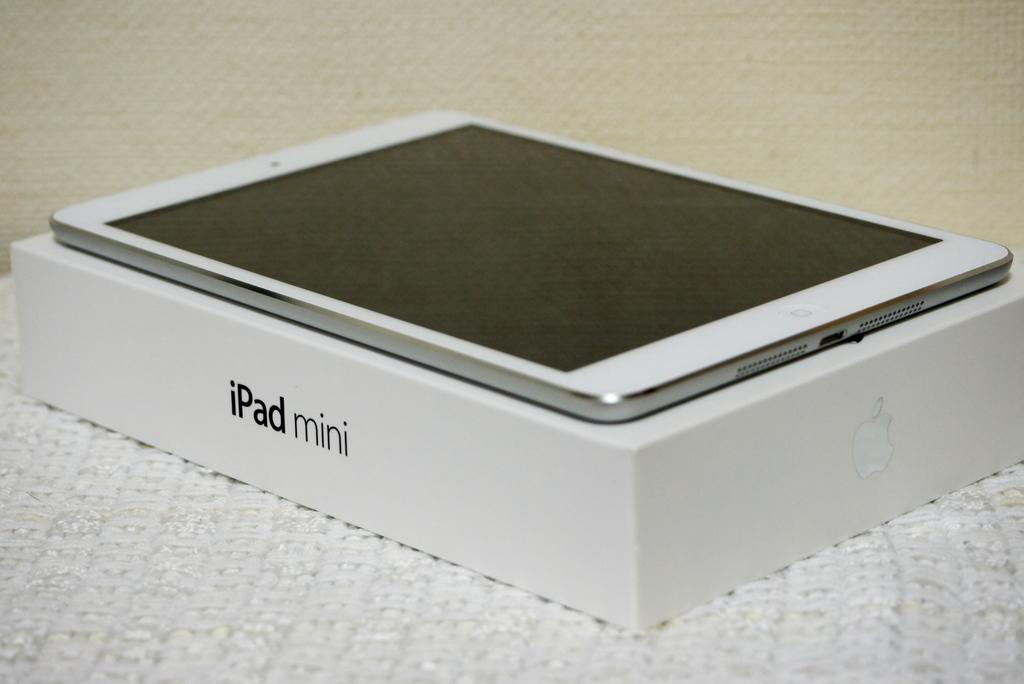<image>
Present a compact description of the photo's key features. A box for an iPad mini has one on top of it. 